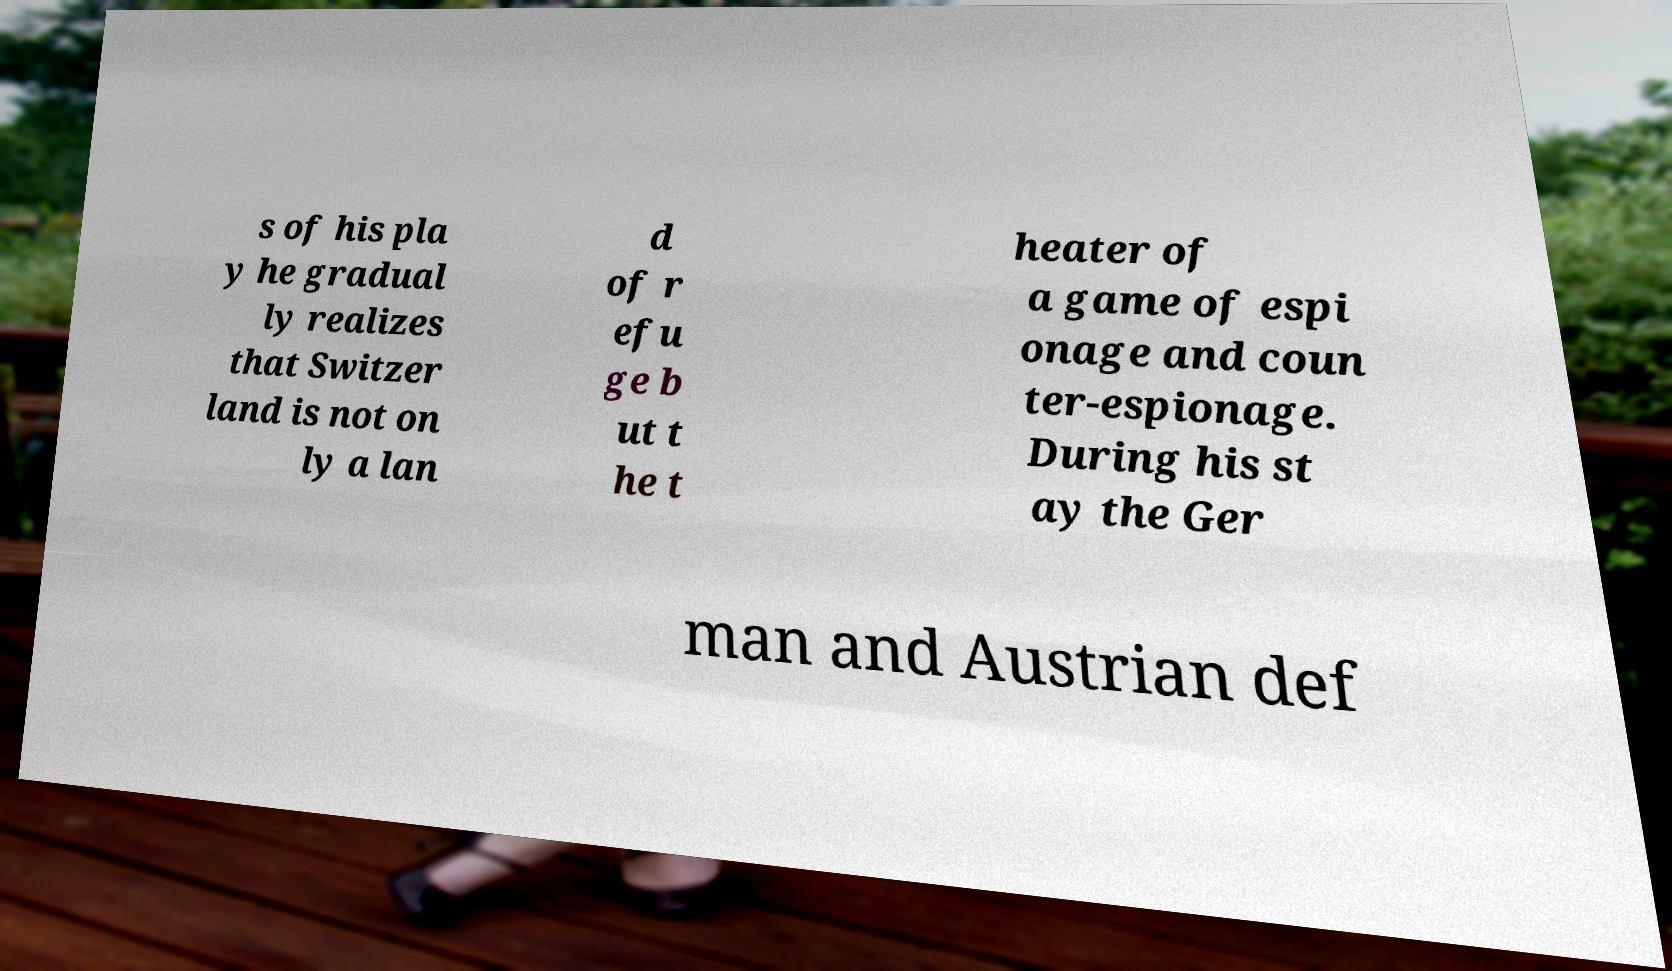For documentation purposes, I need the text within this image transcribed. Could you provide that? s of his pla y he gradual ly realizes that Switzer land is not on ly a lan d of r efu ge b ut t he t heater of a game of espi onage and coun ter-espionage. During his st ay the Ger man and Austrian def 